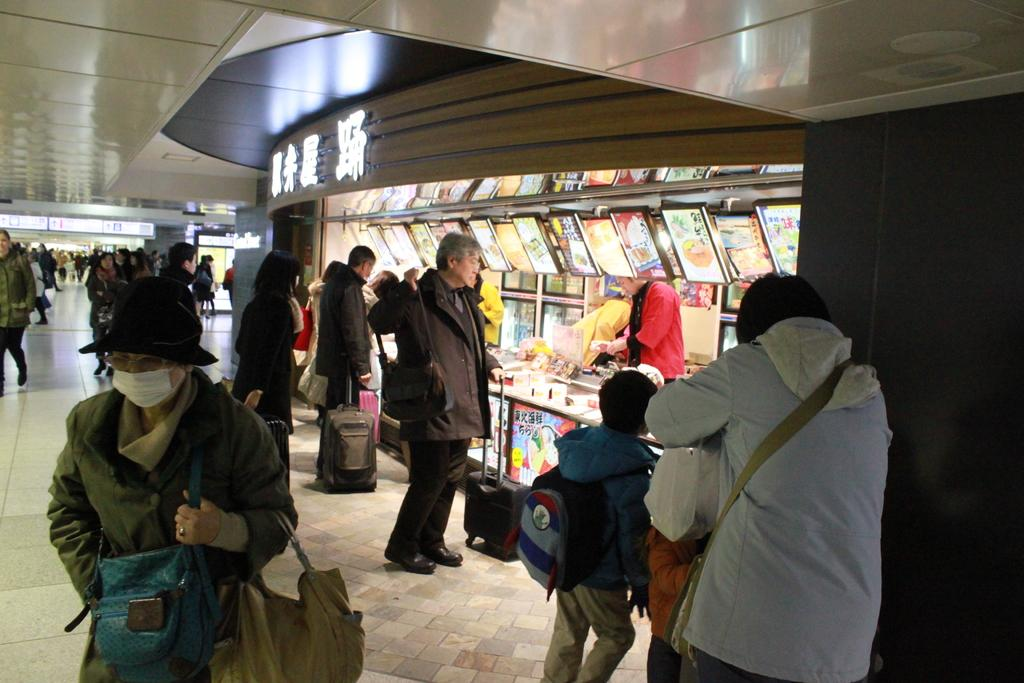What is the main focus of the image? The main focus of the image is the people in the center. What can be seen on the right side of the image? There are stalls on the right side of the image. What is visible at the top of the image? There is a ceiling visible at the top of the image. What is visible at the bottom of the image? There is a floor visible at the bottom of the image. Can you tell me how many guns are visible in the image? There are no guns present in the image. Is there a baby in the image? There is no baby present in the image. 